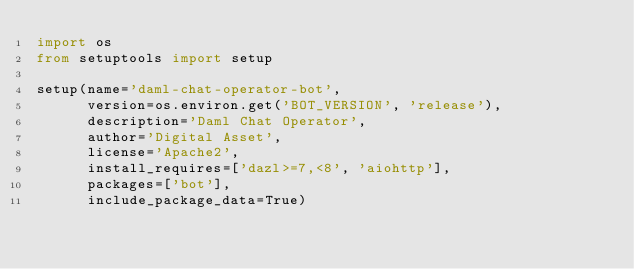Convert code to text. <code><loc_0><loc_0><loc_500><loc_500><_Python_>import os
from setuptools import setup

setup(name='daml-chat-operator-bot',
      version=os.environ.get('BOT_VERSION', 'release'),
      description='Daml Chat Operator',
      author='Digital Asset',
      license='Apache2',
      install_requires=['dazl>=7,<8', 'aiohttp'],
      packages=['bot'],
      include_package_data=True)
</code> 